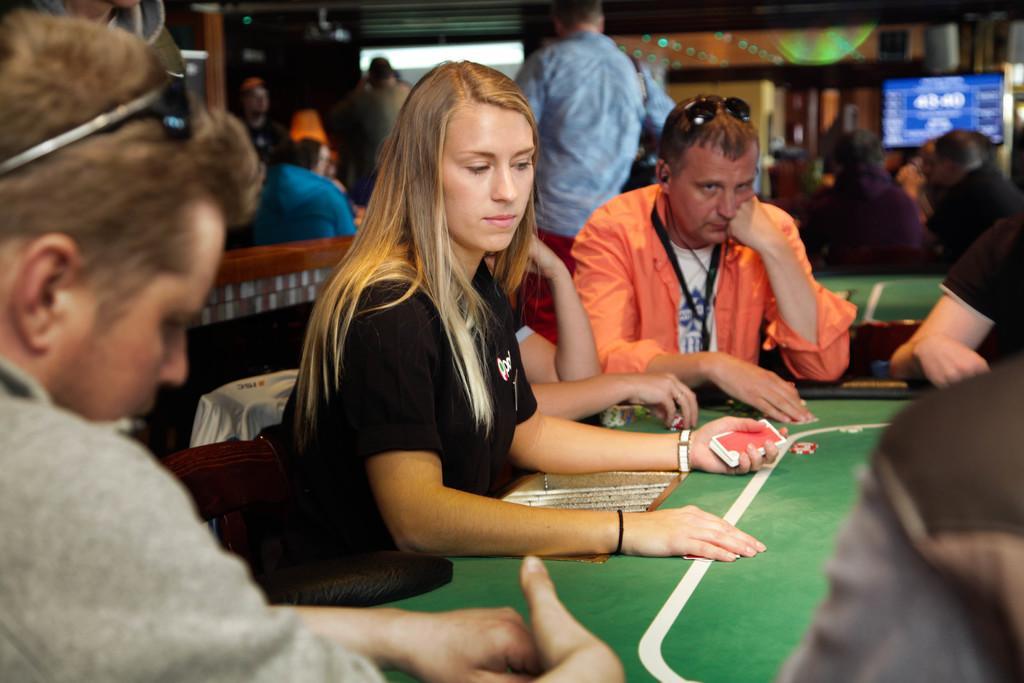Describe this image in one or two sentences. There are few people at the table and a woman is holding cards in her hand. Behind them there are few people and a screen. 